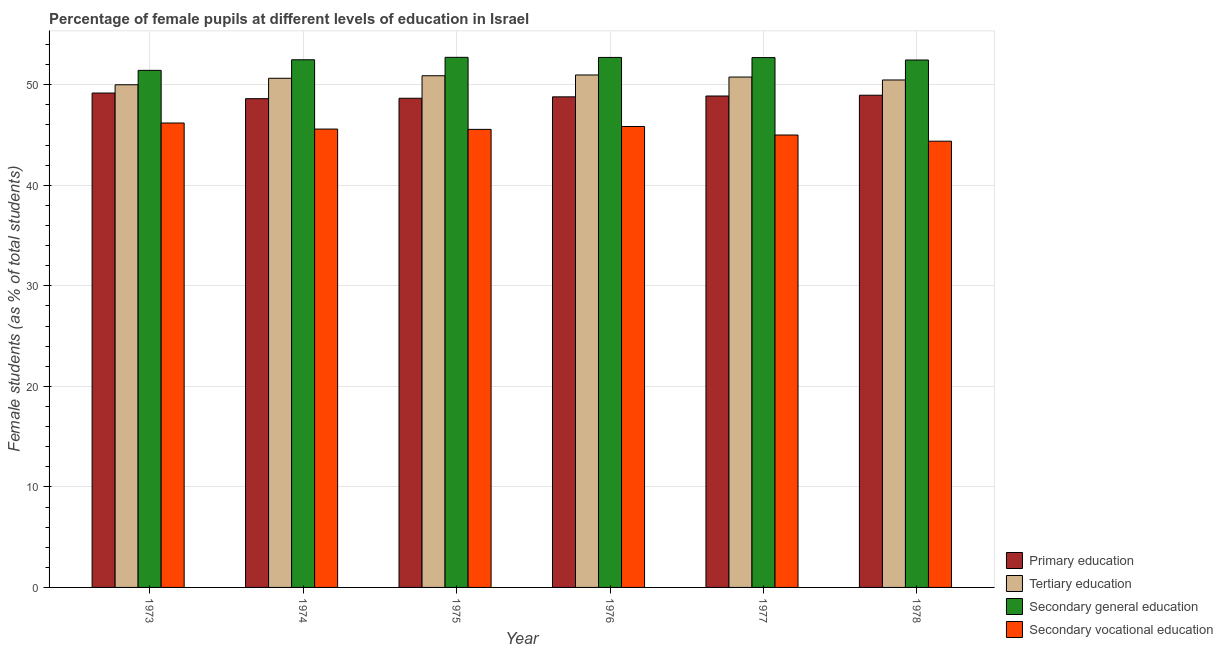How many different coloured bars are there?
Your answer should be compact. 4. Are the number of bars per tick equal to the number of legend labels?
Make the answer very short. Yes. Are the number of bars on each tick of the X-axis equal?
Keep it short and to the point. Yes. How many bars are there on the 5th tick from the right?
Give a very brief answer. 4. What is the label of the 6th group of bars from the left?
Provide a short and direct response. 1978. What is the percentage of female students in secondary vocational education in 1977?
Provide a succinct answer. 45. Across all years, what is the maximum percentage of female students in secondary vocational education?
Your response must be concise. 46.2. Across all years, what is the minimum percentage of female students in primary education?
Keep it short and to the point. 48.62. In which year was the percentage of female students in secondary vocational education minimum?
Provide a succinct answer. 1978. What is the total percentage of female students in secondary vocational education in the graph?
Keep it short and to the point. 272.6. What is the difference between the percentage of female students in tertiary education in 1976 and that in 1978?
Offer a terse response. 0.5. What is the difference between the percentage of female students in secondary education in 1974 and the percentage of female students in secondary vocational education in 1977?
Your answer should be compact. -0.22. What is the average percentage of female students in primary education per year?
Your answer should be compact. 48.85. In the year 1973, what is the difference between the percentage of female students in secondary vocational education and percentage of female students in secondary education?
Provide a succinct answer. 0. In how many years, is the percentage of female students in secondary education greater than 40 %?
Your answer should be very brief. 6. What is the ratio of the percentage of female students in tertiary education in 1976 to that in 1978?
Provide a short and direct response. 1.01. Is the percentage of female students in secondary education in 1973 less than that in 1977?
Provide a short and direct response. Yes. Is the difference between the percentage of female students in secondary education in 1974 and 1978 greater than the difference between the percentage of female students in secondary vocational education in 1974 and 1978?
Provide a short and direct response. No. What is the difference between the highest and the second highest percentage of female students in tertiary education?
Your response must be concise. 0.08. What is the difference between the highest and the lowest percentage of female students in secondary vocational education?
Make the answer very short. 1.81. Is it the case that in every year, the sum of the percentage of female students in primary education and percentage of female students in secondary education is greater than the sum of percentage of female students in tertiary education and percentage of female students in secondary vocational education?
Make the answer very short. No. What does the 4th bar from the left in 1973 represents?
Keep it short and to the point. Secondary vocational education. What does the 3rd bar from the right in 1975 represents?
Ensure brevity in your answer.  Tertiary education. Is it the case that in every year, the sum of the percentage of female students in primary education and percentage of female students in tertiary education is greater than the percentage of female students in secondary education?
Give a very brief answer. Yes. How many bars are there?
Provide a succinct answer. 24. How many years are there in the graph?
Ensure brevity in your answer.  6. Are the values on the major ticks of Y-axis written in scientific E-notation?
Provide a short and direct response. No. Where does the legend appear in the graph?
Your answer should be compact. Bottom right. How many legend labels are there?
Your answer should be very brief. 4. What is the title of the graph?
Your answer should be compact. Percentage of female pupils at different levels of education in Israel. What is the label or title of the X-axis?
Your answer should be very brief. Year. What is the label or title of the Y-axis?
Your answer should be very brief. Female students (as % of total students). What is the Female students (as % of total students) in Primary education in 1973?
Ensure brevity in your answer.  49.18. What is the Female students (as % of total students) of Tertiary education in 1973?
Keep it short and to the point. 50. What is the Female students (as % of total students) in Secondary general education in 1973?
Offer a terse response. 51.43. What is the Female students (as % of total students) of Secondary vocational education in 1973?
Your answer should be very brief. 46.2. What is the Female students (as % of total students) in Primary education in 1974?
Offer a very short reply. 48.62. What is the Female students (as % of total students) of Tertiary education in 1974?
Your response must be concise. 50.65. What is the Female students (as % of total students) of Secondary general education in 1974?
Offer a very short reply. 52.49. What is the Female students (as % of total students) in Secondary vocational education in 1974?
Give a very brief answer. 45.6. What is the Female students (as % of total students) of Primary education in 1975?
Your answer should be very brief. 48.66. What is the Female students (as % of total students) of Tertiary education in 1975?
Make the answer very short. 50.9. What is the Female students (as % of total students) of Secondary general education in 1975?
Your response must be concise. 52.73. What is the Female students (as % of total students) of Secondary vocational education in 1975?
Provide a short and direct response. 45.57. What is the Female students (as % of total students) in Primary education in 1976?
Give a very brief answer. 48.8. What is the Female students (as % of total students) in Tertiary education in 1976?
Your answer should be compact. 50.97. What is the Female students (as % of total students) in Secondary general education in 1976?
Your response must be concise. 52.72. What is the Female students (as % of total students) in Secondary vocational education in 1976?
Give a very brief answer. 45.85. What is the Female students (as % of total students) in Primary education in 1977?
Ensure brevity in your answer.  48.88. What is the Female students (as % of total students) in Tertiary education in 1977?
Offer a terse response. 50.77. What is the Female students (as % of total students) in Secondary general education in 1977?
Your answer should be compact. 52.7. What is the Female students (as % of total students) of Secondary vocational education in 1977?
Offer a terse response. 45. What is the Female students (as % of total students) in Primary education in 1978?
Offer a terse response. 48.96. What is the Female students (as % of total students) in Tertiary education in 1978?
Make the answer very short. 50.48. What is the Female students (as % of total students) of Secondary general education in 1978?
Provide a succinct answer. 52.46. What is the Female students (as % of total students) of Secondary vocational education in 1978?
Provide a succinct answer. 44.39. Across all years, what is the maximum Female students (as % of total students) of Primary education?
Give a very brief answer. 49.18. Across all years, what is the maximum Female students (as % of total students) in Tertiary education?
Ensure brevity in your answer.  50.97. Across all years, what is the maximum Female students (as % of total students) in Secondary general education?
Provide a succinct answer. 52.73. Across all years, what is the maximum Female students (as % of total students) in Secondary vocational education?
Your response must be concise. 46.2. Across all years, what is the minimum Female students (as % of total students) of Primary education?
Your answer should be compact. 48.62. Across all years, what is the minimum Female students (as % of total students) of Tertiary education?
Your response must be concise. 50. Across all years, what is the minimum Female students (as % of total students) in Secondary general education?
Make the answer very short. 51.43. Across all years, what is the minimum Female students (as % of total students) of Secondary vocational education?
Give a very brief answer. 44.39. What is the total Female students (as % of total students) of Primary education in the graph?
Keep it short and to the point. 293.1. What is the total Female students (as % of total students) in Tertiary education in the graph?
Your answer should be compact. 303.77. What is the total Female students (as % of total students) in Secondary general education in the graph?
Your answer should be compact. 314.54. What is the total Female students (as % of total students) of Secondary vocational education in the graph?
Offer a very short reply. 272.6. What is the difference between the Female students (as % of total students) of Primary education in 1973 and that in 1974?
Your answer should be very brief. 0.56. What is the difference between the Female students (as % of total students) of Tertiary education in 1973 and that in 1974?
Your response must be concise. -0.65. What is the difference between the Female students (as % of total students) in Secondary general education in 1973 and that in 1974?
Provide a short and direct response. -1.05. What is the difference between the Female students (as % of total students) of Secondary vocational education in 1973 and that in 1974?
Keep it short and to the point. 0.6. What is the difference between the Female students (as % of total students) in Primary education in 1973 and that in 1975?
Your answer should be very brief. 0.52. What is the difference between the Female students (as % of total students) of Tertiary education in 1973 and that in 1975?
Provide a short and direct response. -0.9. What is the difference between the Female students (as % of total students) of Secondary general education in 1973 and that in 1975?
Keep it short and to the point. -1.3. What is the difference between the Female students (as % of total students) in Secondary vocational education in 1973 and that in 1975?
Provide a short and direct response. 0.63. What is the difference between the Female students (as % of total students) of Primary education in 1973 and that in 1976?
Offer a terse response. 0.38. What is the difference between the Female students (as % of total students) of Tertiary education in 1973 and that in 1976?
Ensure brevity in your answer.  -0.97. What is the difference between the Female students (as % of total students) of Secondary general education in 1973 and that in 1976?
Offer a very short reply. -1.29. What is the difference between the Female students (as % of total students) of Secondary vocational education in 1973 and that in 1976?
Ensure brevity in your answer.  0.35. What is the difference between the Female students (as % of total students) of Primary education in 1973 and that in 1977?
Offer a terse response. 0.3. What is the difference between the Female students (as % of total students) of Tertiary education in 1973 and that in 1977?
Offer a terse response. -0.77. What is the difference between the Female students (as % of total students) of Secondary general education in 1973 and that in 1977?
Keep it short and to the point. -1.27. What is the difference between the Female students (as % of total students) in Secondary vocational education in 1973 and that in 1977?
Ensure brevity in your answer.  1.19. What is the difference between the Female students (as % of total students) in Primary education in 1973 and that in 1978?
Your answer should be compact. 0.22. What is the difference between the Female students (as % of total students) in Tertiary education in 1973 and that in 1978?
Offer a very short reply. -0.48. What is the difference between the Female students (as % of total students) of Secondary general education in 1973 and that in 1978?
Make the answer very short. -1.03. What is the difference between the Female students (as % of total students) in Secondary vocational education in 1973 and that in 1978?
Your answer should be very brief. 1.81. What is the difference between the Female students (as % of total students) in Primary education in 1974 and that in 1975?
Give a very brief answer. -0.04. What is the difference between the Female students (as % of total students) of Tertiary education in 1974 and that in 1975?
Make the answer very short. -0.25. What is the difference between the Female students (as % of total students) in Secondary general education in 1974 and that in 1975?
Ensure brevity in your answer.  -0.24. What is the difference between the Female students (as % of total students) in Secondary vocational education in 1974 and that in 1975?
Keep it short and to the point. 0.03. What is the difference between the Female students (as % of total students) of Primary education in 1974 and that in 1976?
Give a very brief answer. -0.18. What is the difference between the Female students (as % of total students) of Tertiary education in 1974 and that in 1976?
Offer a very short reply. -0.33. What is the difference between the Female students (as % of total students) in Secondary general education in 1974 and that in 1976?
Provide a succinct answer. -0.23. What is the difference between the Female students (as % of total students) in Secondary vocational education in 1974 and that in 1976?
Provide a short and direct response. -0.26. What is the difference between the Female students (as % of total students) of Primary education in 1974 and that in 1977?
Ensure brevity in your answer.  -0.27. What is the difference between the Female students (as % of total students) in Tertiary education in 1974 and that in 1977?
Your response must be concise. -0.12. What is the difference between the Female students (as % of total students) of Secondary general education in 1974 and that in 1977?
Provide a short and direct response. -0.22. What is the difference between the Female students (as % of total students) in Secondary vocational education in 1974 and that in 1977?
Your answer should be compact. 0.59. What is the difference between the Female students (as % of total students) of Primary education in 1974 and that in 1978?
Give a very brief answer. -0.34. What is the difference between the Female students (as % of total students) of Tertiary education in 1974 and that in 1978?
Provide a succinct answer. 0.17. What is the difference between the Female students (as % of total students) of Secondary general education in 1974 and that in 1978?
Offer a terse response. 0.02. What is the difference between the Female students (as % of total students) of Secondary vocational education in 1974 and that in 1978?
Offer a terse response. 1.21. What is the difference between the Female students (as % of total students) of Primary education in 1975 and that in 1976?
Keep it short and to the point. -0.14. What is the difference between the Female students (as % of total students) in Tertiary education in 1975 and that in 1976?
Provide a short and direct response. -0.07. What is the difference between the Female students (as % of total students) of Secondary general education in 1975 and that in 1976?
Your answer should be very brief. 0.01. What is the difference between the Female students (as % of total students) of Secondary vocational education in 1975 and that in 1976?
Ensure brevity in your answer.  -0.29. What is the difference between the Female students (as % of total students) in Primary education in 1975 and that in 1977?
Your response must be concise. -0.22. What is the difference between the Female students (as % of total students) in Tertiary education in 1975 and that in 1977?
Offer a terse response. 0.13. What is the difference between the Female students (as % of total students) of Secondary general education in 1975 and that in 1977?
Your answer should be compact. 0.03. What is the difference between the Female students (as % of total students) of Secondary vocational education in 1975 and that in 1977?
Offer a very short reply. 0.56. What is the difference between the Female students (as % of total students) of Primary education in 1975 and that in 1978?
Give a very brief answer. -0.3. What is the difference between the Female students (as % of total students) of Tertiary education in 1975 and that in 1978?
Give a very brief answer. 0.42. What is the difference between the Female students (as % of total students) in Secondary general education in 1975 and that in 1978?
Provide a short and direct response. 0.27. What is the difference between the Female students (as % of total students) in Secondary vocational education in 1975 and that in 1978?
Ensure brevity in your answer.  1.18. What is the difference between the Female students (as % of total students) in Primary education in 1976 and that in 1977?
Provide a succinct answer. -0.08. What is the difference between the Female students (as % of total students) in Tertiary education in 1976 and that in 1977?
Keep it short and to the point. 0.21. What is the difference between the Female students (as % of total students) of Secondary general education in 1976 and that in 1977?
Your answer should be very brief. 0.02. What is the difference between the Female students (as % of total students) of Secondary vocational education in 1976 and that in 1977?
Provide a short and direct response. 0.85. What is the difference between the Female students (as % of total students) of Primary education in 1976 and that in 1978?
Offer a terse response. -0.16. What is the difference between the Female students (as % of total students) of Tertiary education in 1976 and that in 1978?
Your answer should be very brief. 0.5. What is the difference between the Female students (as % of total students) in Secondary general education in 1976 and that in 1978?
Ensure brevity in your answer.  0.26. What is the difference between the Female students (as % of total students) in Secondary vocational education in 1976 and that in 1978?
Provide a short and direct response. 1.46. What is the difference between the Female students (as % of total students) in Primary education in 1977 and that in 1978?
Provide a short and direct response. -0.08. What is the difference between the Female students (as % of total students) in Tertiary education in 1977 and that in 1978?
Your answer should be compact. 0.29. What is the difference between the Female students (as % of total students) in Secondary general education in 1977 and that in 1978?
Give a very brief answer. 0.24. What is the difference between the Female students (as % of total students) of Secondary vocational education in 1977 and that in 1978?
Make the answer very short. 0.62. What is the difference between the Female students (as % of total students) of Primary education in 1973 and the Female students (as % of total students) of Tertiary education in 1974?
Offer a terse response. -1.47. What is the difference between the Female students (as % of total students) of Primary education in 1973 and the Female students (as % of total students) of Secondary general education in 1974?
Your answer should be compact. -3.31. What is the difference between the Female students (as % of total students) in Primary education in 1973 and the Female students (as % of total students) in Secondary vocational education in 1974?
Your answer should be compact. 3.58. What is the difference between the Female students (as % of total students) of Tertiary education in 1973 and the Female students (as % of total students) of Secondary general education in 1974?
Your answer should be very brief. -2.49. What is the difference between the Female students (as % of total students) in Tertiary education in 1973 and the Female students (as % of total students) in Secondary vocational education in 1974?
Provide a short and direct response. 4.41. What is the difference between the Female students (as % of total students) in Secondary general education in 1973 and the Female students (as % of total students) in Secondary vocational education in 1974?
Give a very brief answer. 5.84. What is the difference between the Female students (as % of total students) in Primary education in 1973 and the Female students (as % of total students) in Tertiary education in 1975?
Offer a very short reply. -1.72. What is the difference between the Female students (as % of total students) in Primary education in 1973 and the Female students (as % of total students) in Secondary general education in 1975?
Your answer should be compact. -3.55. What is the difference between the Female students (as % of total students) of Primary education in 1973 and the Female students (as % of total students) of Secondary vocational education in 1975?
Your answer should be very brief. 3.61. What is the difference between the Female students (as % of total students) in Tertiary education in 1973 and the Female students (as % of total students) in Secondary general education in 1975?
Make the answer very short. -2.73. What is the difference between the Female students (as % of total students) in Tertiary education in 1973 and the Female students (as % of total students) in Secondary vocational education in 1975?
Ensure brevity in your answer.  4.44. What is the difference between the Female students (as % of total students) of Secondary general education in 1973 and the Female students (as % of total students) of Secondary vocational education in 1975?
Your answer should be very brief. 5.87. What is the difference between the Female students (as % of total students) in Primary education in 1973 and the Female students (as % of total students) in Tertiary education in 1976?
Ensure brevity in your answer.  -1.8. What is the difference between the Female students (as % of total students) of Primary education in 1973 and the Female students (as % of total students) of Secondary general education in 1976?
Your answer should be compact. -3.54. What is the difference between the Female students (as % of total students) of Primary education in 1973 and the Female students (as % of total students) of Secondary vocational education in 1976?
Your answer should be very brief. 3.33. What is the difference between the Female students (as % of total students) in Tertiary education in 1973 and the Female students (as % of total students) in Secondary general education in 1976?
Offer a very short reply. -2.72. What is the difference between the Female students (as % of total students) of Tertiary education in 1973 and the Female students (as % of total students) of Secondary vocational education in 1976?
Provide a short and direct response. 4.15. What is the difference between the Female students (as % of total students) in Secondary general education in 1973 and the Female students (as % of total students) in Secondary vocational education in 1976?
Your answer should be very brief. 5.58. What is the difference between the Female students (as % of total students) in Primary education in 1973 and the Female students (as % of total students) in Tertiary education in 1977?
Your response must be concise. -1.59. What is the difference between the Female students (as % of total students) of Primary education in 1973 and the Female students (as % of total students) of Secondary general education in 1977?
Ensure brevity in your answer.  -3.53. What is the difference between the Female students (as % of total students) in Primary education in 1973 and the Female students (as % of total students) in Secondary vocational education in 1977?
Keep it short and to the point. 4.18. What is the difference between the Female students (as % of total students) of Tertiary education in 1973 and the Female students (as % of total students) of Secondary general education in 1977?
Your answer should be compact. -2.7. What is the difference between the Female students (as % of total students) in Tertiary education in 1973 and the Female students (as % of total students) in Secondary vocational education in 1977?
Offer a very short reply. 5. What is the difference between the Female students (as % of total students) in Secondary general education in 1973 and the Female students (as % of total students) in Secondary vocational education in 1977?
Give a very brief answer. 6.43. What is the difference between the Female students (as % of total students) of Primary education in 1973 and the Female students (as % of total students) of Tertiary education in 1978?
Offer a terse response. -1.3. What is the difference between the Female students (as % of total students) in Primary education in 1973 and the Female students (as % of total students) in Secondary general education in 1978?
Offer a very short reply. -3.29. What is the difference between the Female students (as % of total students) of Primary education in 1973 and the Female students (as % of total students) of Secondary vocational education in 1978?
Provide a short and direct response. 4.79. What is the difference between the Female students (as % of total students) in Tertiary education in 1973 and the Female students (as % of total students) in Secondary general education in 1978?
Make the answer very short. -2.46. What is the difference between the Female students (as % of total students) in Tertiary education in 1973 and the Female students (as % of total students) in Secondary vocational education in 1978?
Your response must be concise. 5.61. What is the difference between the Female students (as % of total students) of Secondary general education in 1973 and the Female students (as % of total students) of Secondary vocational education in 1978?
Your answer should be very brief. 7.05. What is the difference between the Female students (as % of total students) in Primary education in 1974 and the Female students (as % of total students) in Tertiary education in 1975?
Your answer should be compact. -2.28. What is the difference between the Female students (as % of total students) in Primary education in 1974 and the Female students (as % of total students) in Secondary general education in 1975?
Ensure brevity in your answer.  -4.11. What is the difference between the Female students (as % of total students) of Primary education in 1974 and the Female students (as % of total students) of Secondary vocational education in 1975?
Offer a terse response. 3.05. What is the difference between the Female students (as % of total students) in Tertiary education in 1974 and the Female students (as % of total students) in Secondary general education in 1975?
Your response must be concise. -2.08. What is the difference between the Female students (as % of total students) of Tertiary education in 1974 and the Female students (as % of total students) of Secondary vocational education in 1975?
Offer a terse response. 5.08. What is the difference between the Female students (as % of total students) in Secondary general education in 1974 and the Female students (as % of total students) in Secondary vocational education in 1975?
Your answer should be very brief. 6.92. What is the difference between the Female students (as % of total students) of Primary education in 1974 and the Female students (as % of total students) of Tertiary education in 1976?
Offer a very short reply. -2.36. What is the difference between the Female students (as % of total students) in Primary education in 1974 and the Female students (as % of total students) in Secondary general education in 1976?
Your response must be concise. -4.1. What is the difference between the Female students (as % of total students) in Primary education in 1974 and the Female students (as % of total students) in Secondary vocational education in 1976?
Provide a succinct answer. 2.77. What is the difference between the Female students (as % of total students) of Tertiary education in 1974 and the Female students (as % of total students) of Secondary general education in 1976?
Ensure brevity in your answer.  -2.07. What is the difference between the Female students (as % of total students) in Tertiary education in 1974 and the Female students (as % of total students) in Secondary vocational education in 1976?
Give a very brief answer. 4.8. What is the difference between the Female students (as % of total students) in Secondary general education in 1974 and the Female students (as % of total students) in Secondary vocational education in 1976?
Offer a very short reply. 6.64. What is the difference between the Female students (as % of total students) in Primary education in 1974 and the Female students (as % of total students) in Tertiary education in 1977?
Make the answer very short. -2.15. What is the difference between the Female students (as % of total students) of Primary education in 1974 and the Female students (as % of total students) of Secondary general education in 1977?
Your response must be concise. -4.09. What is the difference between the Female students (as % of total students) in Primary education in 1974 and the Female students (as % of total students) in Secondary vocational education in 1977?
Your answer should be compact. 3.61. What is the difference between the Female students (as % of total students) of Tertiary education in 1974 and the Female students (as % of total students) of Secondary general education in 1977?
Offer a terse response. -2.06. What is the difference between the Female students (as % of total students) in Tertiary education in 1974 and the Female students (as % of total students) in Secondary vocational education in 1977?
Offer a terse response. 5.64. What is the difference between the Female students (as % of total students) of Secondary general education in 1974 and the Female students (as % of total students) of Secondary vocational education in 1977?
Offer a terse response. 7.48. What is the difference between the Female students (as % of total students) in Primary education in 1974 and the Female students (as % of total students) in Tertiary education in 1978?
Your answer should be compact. -1.86. What is the difference between the Female students (as % of total students) in Primary education in 1974 and the Female students (as % of total students) in Secondary general education in 1978?
Keep it short and to the point. -3.85. What is the difference between the Female students (as % of total students) in Primary education in 1974 and the Female students (as % of total students) in Secondary vocational education in 1978?
Provide a succinct answer. 4.23. What is the difference between the Female students (as % of total students) in Tertiary education in 1974 and the Female students (as % of total students) in Secondary general education in 1978?
Your answer should be compact. -1.82. What is the difference between the Female students (as % of total students) in Tertiary education in 1974 and the Female students (as % of total students) in Secondary vocational education in 1978?
Provide a short and direct response. 6.26. What is the difference between the Female students (as % of total students) in Secondary general education in 1974 and the Female students (as % of total students) in Secondary vocational education in 1978?
Keep it short and to the point. 8.1. What is the difference between the Female students (as % of total students) in Primary education in 1975 and the Female students (as % of total students) in Tertiary education in 1976?
Keep it short and to the point. -2.31. What is the difference between the Female students (as % of total students) of Primary education in 1975 and the Female students (as % of total students) of Secondary general education in 1976?
Offer a very short reply. -4.06. What is the difference between the Female students (as % of total students) of Primary education in 1975 and the Female students (as % of total students) of Secondary vocational education in 1976?
Provide a short and direct response. 2.81. What is the difference between the Female students (as % of total students) of Tertiary education in 1975 and the Female students (as % of total students) of Secondary general education in 1976?
Your response must be concise. -1.82. What is the difference between the Female students (as % of total students) of Tertiary education in 1975 and the Female students (as % of total students) of Secondary vocational education in 1976?
Your response must be concise. 5.05. What is the difference between the Female students (as % of total students) in Secondary general education in 1975 and the Female students (as % of total students) in Secondary vocational education in 1976?
Ensure brevity in your answer.  6.88. What is the difference between the Female students (as % of total students) of Primary education in 1975 and the Female students (as % of total students) of Tertiary education in 1977?
Your response must be concise. -2.11. What is the difference between the Female students (as % of total students) in Primary education in 1975 and the Female students (as % of total students) in Secondary general education in 1977?
Keep it short and to the point. -4.04. What is the difference between the Female students (as % of total students) in Primary education in 1975 and the Female students (as % of total students) in Secondary vocational education in 1977?
Your answer should be compact. 3.66. What is the difference between the Female students (as % of total students) of Tertiary education in 1975 and the Female students (as % of total students) of Secondary general education in 1977?
Make the answer very short. -1.8. What is the difference between the Female students (as % of total students) of Tertiary education in 1975 and the Female students (as % of total students) of Secondary vocational education in 1977?
Give a very brief answer. 5.9. What is the difference between the Female students (as % of total students) of Secondary general education in 1975 and the Female students (as % of total students) of Secondary vocational education in 1977?
Offer a terse response. 7.73. What is the difference between the Female students (as % of total students) of Primary education in 1975 and the Female students (as % of total students) of Tertiary education in 1978?
Your answer should be compact. -1.82. What is the difference between the Female students (as % of total students) in Primary education in 1975 and the Female students (as % of total students) in Secondary general education in 1978?
Offer a very short reply. -3.8. What is the difference between the Female students (as % of total students) in Primary education in 1975 and the Female students (as % of total students) in Secondary vocational education in 1978?
Keep it short and to the point. 4.27. What is the difference between the Female students (as % of total students) in Tertiary education in 1975 and the Female students (as % of total students) in Secondary general education in 1978?
Offer a very short reply. -1.56. What is the difference between the Female students (as % of total students) of Tertiary education in 1975 and the Female students (as % of total students) of Secondary vocational education in 1978?
Your answer should be very brief. 6.51. What is the difference between the Female students (as % of total students) of Secondary general education in 1975 and the Female students (as % of total students) of Secondary vocational education in 1978?
Ensure brevity in your answer.  8.34. What is the difference between the Female students (as % of total students) of Primary education in 1976 and the Female students (as % of total students) of Tertiary education in 1977?
Provide a short and direct response. -1.97. What is the difference between the Female students (as % of total students) of Primary education in 1976 and the Female students (as % of total students) of Secondary general education in 1977?
Your response must be concise. -3.9. What is the difference between the Female students (as % of total students) in Primary education in 1976 and the Female students (as % of total students) in Secondary vocational education in 1977?
Make the answer very short. 3.8. What is the difference between the Female students (as % of total students) of Tertiary education in 1976 and the Female students (as % of total students) of Secondary general education in 1977?
Offer a terse response. -1.73. What is the difference between the Female students (as % of total students) of Tertiary education in 1976 and the Female students (as % of total students) of Secondary vocational education in 1977?
Provide a succinct answer. 5.97. What is the difference between the Female students (as % of total students) of Secondary general education in 1976 and the Female students (as % of total students) of Secondary vocational education in 1977?
Provide a succinct answer. 7.72. What is the difference between the Female students (as % of total students) of Primary education in 1976 and the Female students (as % of total students) of Tertiary education in 1978?
Ensure brevity in your answer.  -1.68. What is the difference between the Female students (as % of total students) of Primary education in 1976 and the Female students (as % of total students) of Secondary general education in 1978?
Offer a very short reply. -3.67. What is the difference between the Female students (as % of total students) in Primary education in 1976 and the Female students (as % of total students) in Secondary vocational education in 1978?
Provide a succinct answer. 4.41. What is the difference between the Female students (as % of total students) of Tertiary education in 1976 and the Female students (as % of total students) of Secondary general education in 1978?
Your answer should be compact. -1.49. What is the difference between the Female students (as % of total students) of Tertiary education in 1976 and the Female students (as % of total students) of Secondary vocational education in 1978?
Provide a succinct answer. 6.59. What is the difference between the Female students (as % of total students) of Secondary general education in 1976 and the Female students (as % of total students) of Secondary vocational education in 1978?
Your answer should be compact. 8.33. What is the difference between the Female students (as % of total students) in Primary education in 1977 and the Female students (as % of total students) in Tertiary education in 1978?
Ensure brevity in your answer.  -1.59. What is the difference between the Female students (as % of total students) in Primary education in 1977 and the Female students (as % of total students) in Secondary general education in 1978?
Your answer should be very brief. -3.58. What is the difference between the Female students (as % of total students) of Primary education in 1977 and the Female students (as % of total students) of Secondary vocational education in 1978?
Keep it short and to the point. 4.5. What is the difference between the Female students (as % of total students) in Tertiary education in 1977 and the Female students (as % of total students) in Secondary general education in 1978?
Keep it short and to the point. -1.7. What is the difference between the Female students (as % of total students) in Tertiary education in 1977 and the Female students (as % of total students) in Secondary vocational education in 1978?
Your answer should be very brief. 6.38. What is the difference between the Female students (as % of total students) of Secondary general education in 1977 and the Female students (as % of total students) of Secondary vocational education in 1978?
Provide a succinct answer. 8.32. What is the average Female students (as % of total students) in Primary education per year?
Your response must be concise. 48.85. What is the average Female students (as % of total students) of Tertiary education per year?
Ensure brevity in your answer.  50.63. What is the average Female students (as % of total students) of Secondary general education per year?
Offer a terse response. 52.42. What is the average Female students (as % of total students) of Secondary vocational education per year?
Your answer should be very brief. 45.43. In the year 1973, what is the difference between the Female students (as % of total students) of Primary education and Female students (as % of total students) of Tertiary education?
Your answer should be compact. -0.82. In the year 1973, what is the difference between the Female students (as % of total students) of Primary education and Female students (as % of total students) of Secondary general education?
Ensure brevity in your answer.  -2.25. In the year 1973, what is the difference between the Female students (as % of total students) of Primary education and Female students (as % of total students) of Secondary vocational education?
Provide a succinct answer. 2.98. In the year 1973, what is the difference between the Female students (as % of total students) of Tertiary education and Female students (as % of total students) of Secondary general education?
Make the answer very short. -1.43. In the year 1973, what is the difference between the Female students (as % of total students) in Tertiary education and Female students (as % of total students) in Secondary vocational education?
Give a very brief answer. 3.8. In the year 1973, what is the difference between the Female students (as % of total students) of Secondary general education and Female students (as % of total students) of Secondary vocational education?
Provide a short and direct response. 5.24. In the year 1974, what is the difference between the Female students (as % of total students) of Primary education and Female students (as % of total students) of Tertiary education?
Give a very brief answer. -2.03. In the year 1974, what is the difference between the Female students (as % of total students) of Primary education and Female students (as % of total students) of Secondary general education?
Your answer should be compact. -3.87. In the year 1974, what is the difference between the Female students (as % of total students) in Primary education and Female students (as % of total students) in Secondary vocational education?
Your answer should be very brief. 3.02. In the year 1974, what is the difference between the Female students (as % of total students) of Tertiary education and Female students (as % of total students) of Secondary general education?
Keep it short and to the point. -1.84. In the year 1974, what is the difference between the Female students (as % of total students) in Tertiary education and Female students (as % of total students) in Secondary vocational education?
Your answer should be compact. 5.05. In the year 1974, what is the difference between the Female students (as % of total students) in Secondary general education and Female students (as % of total students) in Secondary vocational education?
Your response must be concise. 6.89. In the year 1975, what is the difference between the Female students (as % of total students) of Primary education and Female students (as % of total students) of Tertiary education?
Offer a very short reply. -2.24. In the year 1975, what is the difference between the Female students (as % of total students) of Primary education and Female students (as % of total students) of Secondary general education?
Offer a very short reply. -4.07. In the year 1975, what is the difference between the Female students (as % of total students) in Primary education and Female students (as % of total students) in Secondary vocational education?
Ensure brevity in your answer.  3.1. In the year 1975, what is the difference between the Female students (as % of total students) in Tertiary education and Female students (as % of total students) in Secondary general education?
Provide a succinct answer. -1.83. In the year 1975, what is the difference between the Female students (as % of total students) of Tertiary education and Female students (as % of total students) of Secondary vocational education?
Your answer should be very brief. 5.33. In the year 1975, what is the difference between the Female students (as % of total students) in Secondary general education and Female students (as % of total students) in Secondary vocational education?
Your answer should be compact. 7.17. In the year 1976, what is the difference between the Female students (as % of total students) of Primary education and Female students (as % of total students) of Tertiary education?
Provide a short and direct response. -2.18. In the year 1976, what is the difference between the Female students (as % of total students) in Primary education and Female students (as % of total students) in Secondary general education?
Keep it short and to the point. -3.92. In the year 1976, what is the difference between the Female students (as % of total students) in Primary education and Female students (as % of total students) in Secondary vocational education?
Provide a succinct answer. 2.95. In the year 1976, what is the difference between the Female students (as % of total students) in Tertiary education and Female students (as % of total students) in Secondary general education?
Your answer should be very brief. -1.75. In the year 1976, what is the difference between the Female students (as % of total students) in Tertiary education and Female students (as % of total students) in Secondary vocational education?
Your response must be concise. 5.12. In the year 1976, what is the difference between the Female students (as % of total students) of Secondary general education and Female students (as % of total students) of Secondary vocational education?
Provide a succinct answer. 6.87. In the year 1977, what is the difference between the Female students (as % of total students) in Primary education and Female students (as % of total students) in Tertiary education?
Offer a very short reply. -1.89. In the year 1977, what is the difference between the Female students (as % of total students) in Primary education and Female students (as % of total students) in Secondary general education?
Provide a succinct answer. -3.82. In the year 1977, what is the difference between the Female students (as % of total students) in Primary education and Female students (as % of total students) in Secondary vocational education?
Your answer should be compact. 3.88. In the year 1977, what is the difference between the Female students (as % of total students) of Tertiary education and Female students (as % of total students) of Secondary general education?
Give a very brief answer. -1.93. In the year 1977, what is the difference between the Female students (as % of total students) of Tertiary education and Female students (as % of total students) of Secondary vocational education?
Your answer should be compact. 5.77. In the year 1977, what is the difference between the Female students (as % of total students) of Secondary general education and Female students (as % of total students) of Secondary vocational education?
Offer a terse response. 7.7. In the year 1978, what is the difference between the Female students (as % of total students) of Primary education and Female students (as % of total students) of Tertiary education?
Your response must be concise. -1.52. In the year 1978, what is the difference between the Female students (as % of total students) in Primary education and Female students (as % of total students) in Secondary general education?
Your response must be concise. -3.5. In the year 1978, what is the difference between the Female students (as % of total students) in Primary education and Female students (as % of total students) in Secondary vocational education?
Give a very brief answer. 4.57. In the year 1978, what is the difference between the Female students (as % of total students) of Tertiary education and Female students (as % of total students) of Secondary general education?
Your response must be concise. -1.99. In the year 1978, what is the difference between the Female students (as % of total students) of Tertiary education and Female students (as % of total students) of Secondary vocational education?
Your answer should be very brief. 6.09. In the year 1978, what is the difference between the Female students (as % of total students) of Secondary general education and Female students (as % of total students) of Secondary vocational education?
Provide a succinct answer. 8.08. What is the ratio of the Female students (as % of total students) of Primary education in 1973 to that in 1974?
Ensure brevity in your answer.  1.01. What is the ratio of the Female students (as % of total students) of Tertiary education in 1973 to that in 1974?
Offer a very short reply. 0.99. What is the ratio of the Female students (as % of total students) of Secondary general education in 1973 to that in 1974?
Provide a succinct answer. 0.98. What is the ratio of the Female students (as % of total students) of Secondary vocational education in 1973 to that in 1974?
Provide a succinct answer. 1.01. What is the ratio of the Female students (as % of total students) of Primary education in 1973 to that in 1975?
Your answer should be very brief. 1.01. What is the ratio of the Female students (as % of total students) of Tertiary education in 1973 to that in 1975?
Offer a very short reply. 0.98. What is the ratio of the Female students (as % of total students) in Secondary general education in 1973 to that in 1975?
Make the answer very short. 0.98. What is the ratio of the Female students (as % of total students) in Secondary vocational education in 1973 to that in 1975?
Offer a terse response. 1.01. What is the ratio of the Female students (as % of total students) in Primary education in 1973 to that in 1976?
Ensure brevity in your answer.  1.01. What is the ratio of the Female students (as % of total students) in Tertiary education in 1973 to that in 1976?
Your response must be concise. 0.98. What is the ratio of the Female students (as % of total students) of Secondary general education in 1973 to that in 1976?
Provide a succinct answer. 0.98. What is the ratio of the Female students (as % of total students) in Secondary vocational education in 1973 to that in 1976?
Your response must be concise. 1.01. What is the ratio of the Female students (as % of total students) in Tertiary education in 1973 to that in 1977?
Offer a terse response. 0.98. What is the ratio of the Female students (as % of total students) of Secondary general education in 1973 to that in 1977?
Your answer should be very brief. 0.98. What is the ratio of the Female students (as % of total students) of Secondary vocational education in 1973 to that in 1977?
Keep it short and to the point. 1.03. What is the ratio of the Female students (as % of total students) of Tertiary education in 1973 to that in 1978?
Your answer should be compact. 0.99. What is the ratio of the Female students (as % of total students) in Secondary general education in 1973 to that in 1978?
Give a very brief answer. 0.98. What is the ratio of the Female students (as % of total students) of Secondary vocational education in 1973 to that in 1978?
Offer a terse response. 1.04. What is the ratio of the Female students (as % of total students) of Primary education in 1974 to that in 1975?
Your response must be concise. 1. What is the ratio of the Female students (as % of total students) in Secondary general education in 1974 to that in 1975?
Provide a short and direct response. 1. What is the ratio of the Female students (as % of total students) of Secondary vocational education in 1974 to that in 1975?
Keep it short and to the point. 1. What is the ratio of the Female students (as % of total students) in Primary education in 1974 to that in 1976?
Offer a very short reply. 1. What is the ratio of the Female students (as % of total students) in Tertiary education in 1974 to that in 1976?
Your answer should be compact. 0.99. What is the ratio of the Female students (as % of total students) of Secondary vocational education in 1974 to that in 1976?
Offer a very short reply. 0.99. What is the ratio of the Female students (as % of total students) of Secondary vocational education in 1974 to that in 1977?
Your answer should be very brief. 1.01. What is the ratio of the Female students (as % of total students) in Primary education in 1974 to that in 1978?
Your answer should be compact. 0.99. What is the ratio of the Female students (as % of total students) of Tertiary education in 1974 to that in 1978?
Make the answer very short. 1. What is the ratio of the Female students (as % of total students) in Secondary vocational education in 1974 to that in 1978?
Keep it short and to the point. 1.03. What is the ratio of the Female students (as % of total students) of Primary education in 1975 to that in 1976?
Give a very brief answer. 1. What is the ratio of the Female students (as % of total students) in Tertiary education in 1975 to that in 1976?
Provide a short and direct response. 1. What is the ratio of the Female students (as % of total students) of Tertiary education in 1975 to that in 1977?
Give a very brief answer. 1. What is the ratio of the Female students (as % of total students) in Secondary vocational education in 1975 to that in 1977?
Provide a succinct answer. 1.01. What is the ratio of the Female students (as % of total students) of Primary education in 1975 to that in 1978?
Give a very brief answer. 0.99. What is the ratio of the Female students (as % of total students) in Tertiary education in 1975 to that in 1978?
Make the answer very short. 1.01. What is the ratio of the Female students (as % of total students) in Secondary general education in 1975 to that in 1978?
Your response must be concise. 1.01. What is the ratio of the Female students (as % of total students) of Secondary vocational education in 1975 to that in 1978?
Make the answer very short. 1.03. What is the ratio of the Female students (as % of total students) of Primary education in 1976 to that in 1977?
Your response must be concise. 1. What is the ratio of the Female students (as % of total students) of Tertiary education in 1976 to that in 1977?
Your response must be concise. 1. What is the ratio of the Female students (as % of total students) in Secondary general education in 1976 to that in 1977?
Your response must be concise. 1. What is the ratio of the Female students (as % of total students) in Secondary vocational education in 1976 to that in 1977?
Make the answer very short. 1.02. What is the ratio of the Female students (as % of total students) in Primary education in 1976 to that in 1978?
Ensure brevity in your answer.  1. What is the ratio of the Female students (as % of total students) in Tertiary education in 1976 to that in 1978?
Offer a terse response. 1.01. What is the ratio of the Female students (as % of total students) of Secondary general education in 1976 to that in 1978?
Keep it short and to the point. 1. What is the ratio of the Female students (as % of total students) of Secondary vocational education in 1976 to that in 1978?
Make the answer very short. 1.03. What is the ratio of the Female students (as % of total students) of Secondary vocational education in 1977 to that in 1978?
Offer a very short reply. 1.01. What is the difference between the highest and the second highest Female students (as % of total students) of Primary education?
Give a very brief answer. 0.22. What is the difference between the highest and the second highest Female students (as % of total students) in Tertiary education?
Give a very brief answer. 0.07. What is the difference between the highest and the second highest Female students (as % of total students) of Secondary general education?
Your answer should be very brief. 0.01. What is the difference between the highest and the second highest Female students (as % of total students) in Secondary vocational education?
Offer a terse response. 0.35. What is the difference between the highest and the lowest Female students (as % of total students) of Primary education?
Keep it short and to the point. 0.56. What is the difference between the highest and the lowest Female students (as % of total students) in Tertiary education?
Keep it short and to the point. 0.97. What is the difference between the highest and the lowest Female students (as % of total students) in Secondary general education?
Give a very brief answer. 1.3. What is the difference between the highest and the lowest Female students (as % of total students) of Secondary vocational education?
Your answer should be compact. 1.81. 